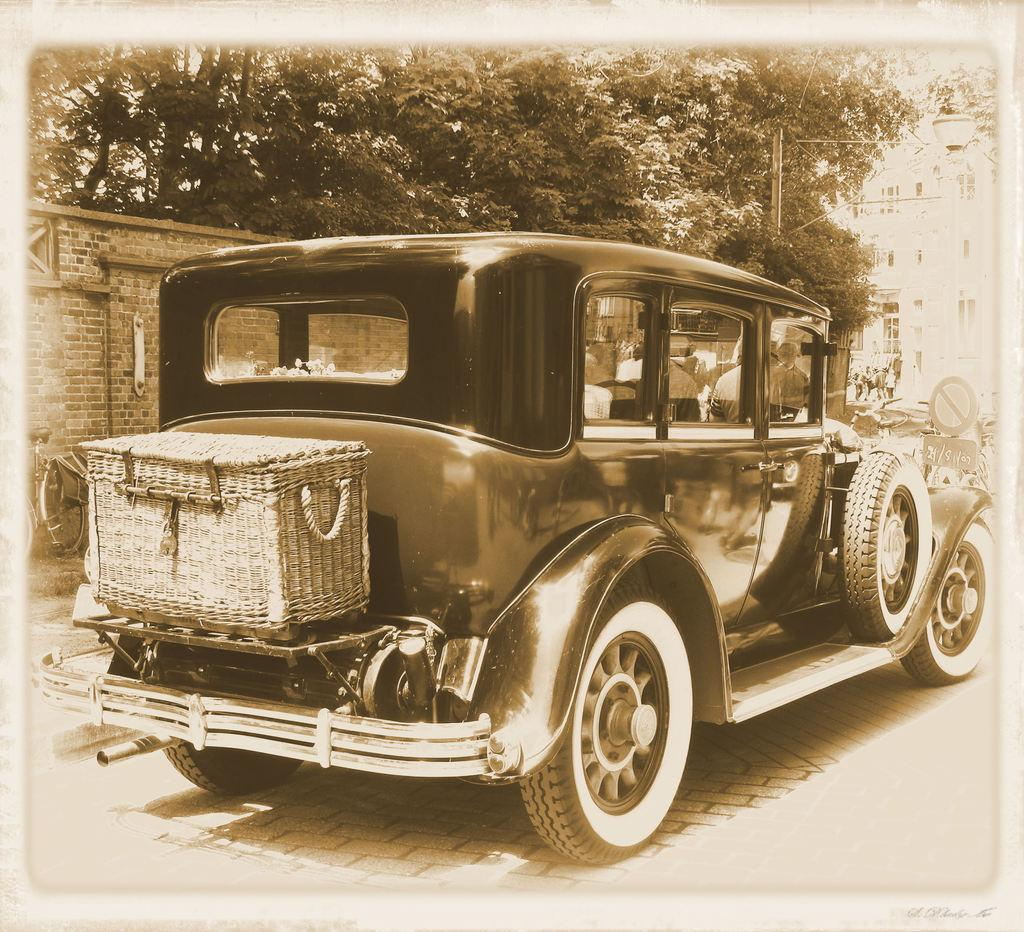What object can be seen in the image that is used for carrying items? There is a basket in the image that is used for carrying items. Where is the basket located in the image? The basket is placed in a specific location in the image. What type of vehicle can be seen on the road in the image? There is an old car on the road in the image. What type of structure is present in the image? There is a brick wall in the image. What type of natural elements are present in the image? Trees are present in the image. What type of sign is present in the image? There is a caution board in the image. What type of man-made structures can be seen in the background of the image? Buildings are visible in the background of the image. How many graves can be seen in the image? There are no graves or cemeteries present in the image. What type of boundary is present in the image? There is no boundary present in the image. 